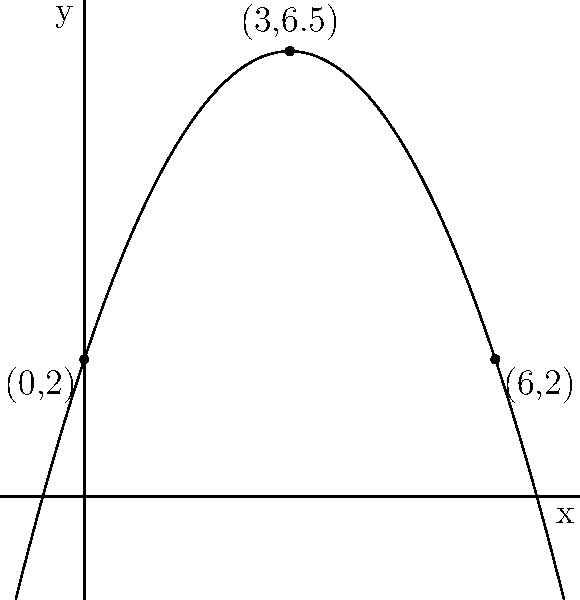The trajectory of a gymnast's somersault can be modeled by the polynomial function $f(x) = -0.5x^2 + 3x + 2$, where $x$ represents the horizontal distance traveled (in meters) and $f(x)$ represents the height (in meters). Based on the graph, what is the maximum height reached by the gymnast during the somersault? To find the maximum height of the somersault, we need to follow these steps:

1) The maximum height occurs at the vertex of the parabola.

2) For a quadratic function in the form $f(x) = ax^2 + bx + c$, the x-coordinate of the vertex is given by $x = -\frac{b}{2a}$.

3) In this case, $a = -0.5$, $b = 3$, and $c = 2$.

4) Substituting these values:
   $x = -\frac{3}{2(-0.5)} = 3$

5) To find the maximum height, we need to calculate $f(3)$:
   $f(3) = -0.5(3)^2 + 3(3) + 2$
         $= -0.5(9) + 9 + 2$
         $= -4.5 + 9 + 2$
         $= 6.5$

6) We can verify this on the graph, where the highest point is indeed at (3, 6.5).

Therefore, the maximum height reached by the gymnast during the somersault is 6.5 meters.
Answer: 6.5 meters 